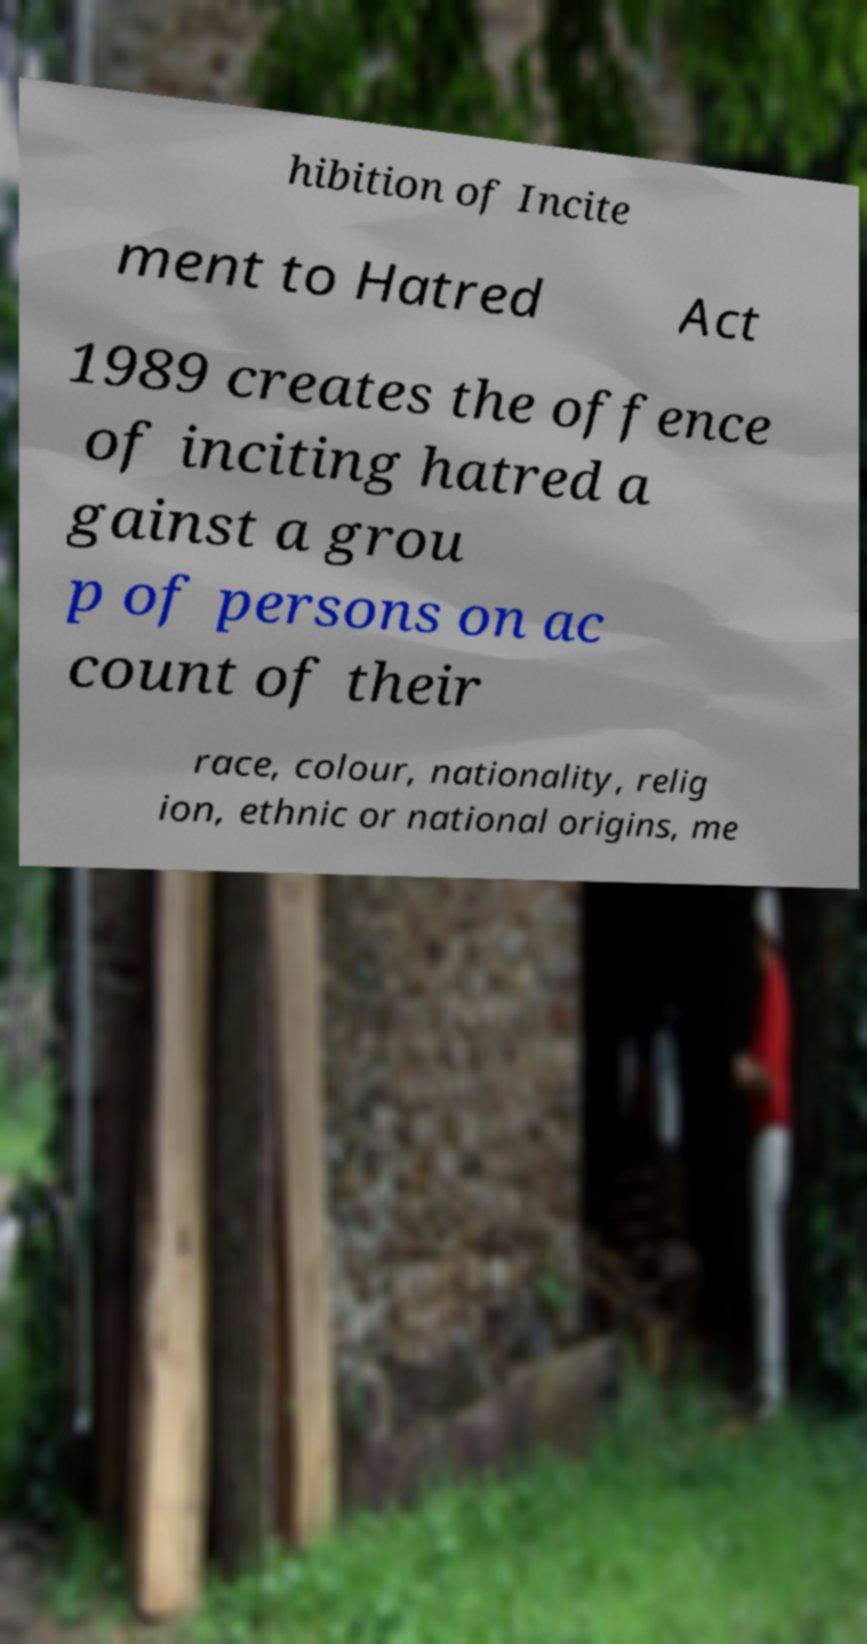Please read and relay the text visible in this image. What does it say? hibition of Incite ment to Hatred Act 1989 creates the offence of inciting hatred a gainst a grou p of persons on ac count of their race, colour, nationality, relig ion, ethnic or national origins, me 